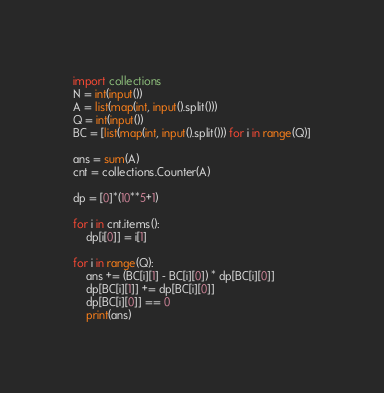<code> <loc_0><loc_0><loc_500><loc_500><_Python_>import collections
N = int(input())
A = list(map(int, input().split()))
Q = int(input())
BC = [list(map(int, input().split())) for i in range(Q)]

ans = sum(A)
cnt = collections.Counter(A)

dp = [0]*(10**5+1)

for i in cnt.items():
    dp[i[0]] = i[1]

for i in range(Q):
    ans += (BC[i][1] - BC[i][0]) * dp[BC[i][0]]
    dp[BC[i][1]] += dp[BC[i][0]]
    dp[BC[i][0]] == 0
    print(ans)
</code> 